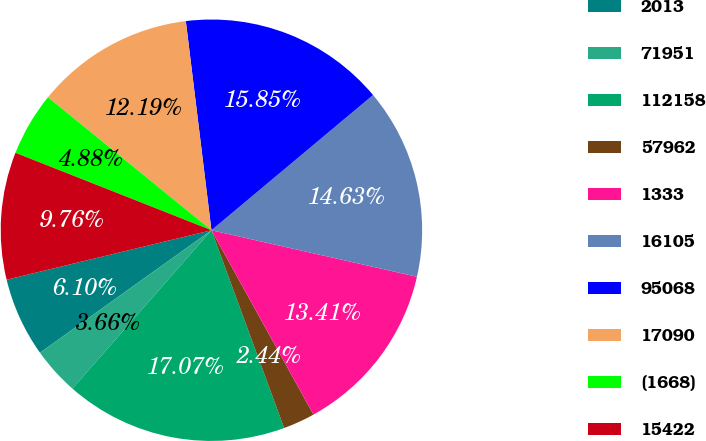<chart> <loc_0><loc_0><loc_500><loc_500><pie_chart><fcel>2013<fcel>71951<fcel>112158<fcel>57962<fcel>1333<fcel>16105<fcel>95068<fcel>17090<fcel>(1668)<fcel>15422<nl><fcel>6.1%<fcel>3.66%<fcel>17.07%<fcel>2.44%<fcel>13.41%<fcel>14.63%<fcel>15.85%<fcel>12.19%<fcel>4.88%<fcel>9.76%<nl></chart> 